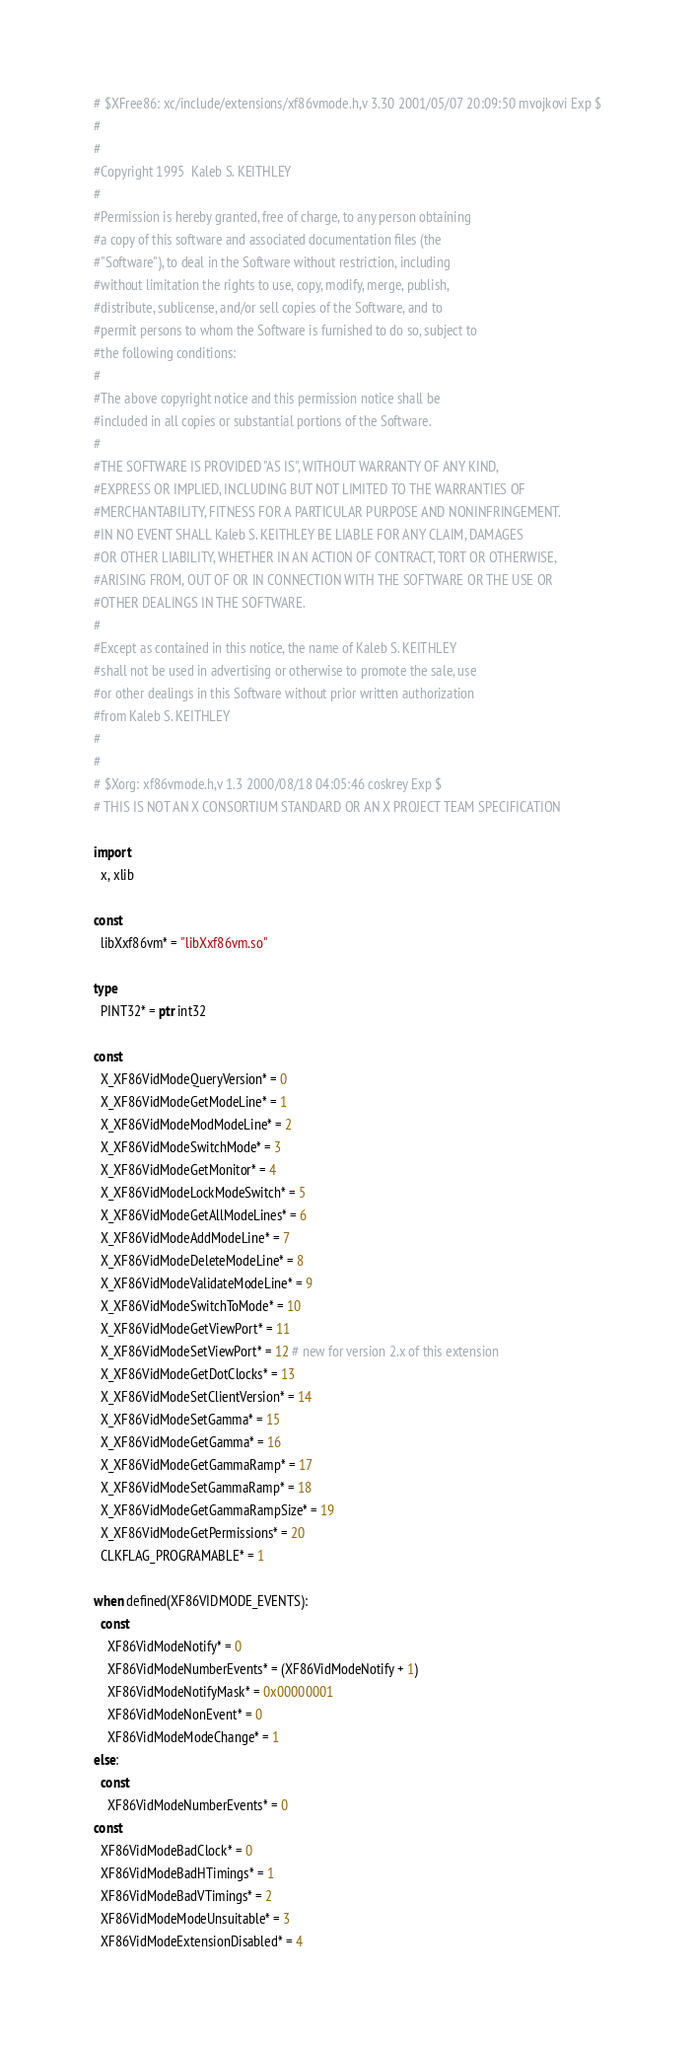Convert code to text. <code><loc_0><loc_0><loc_500><loc_500><_Nim_># $XFree86: xc/include/extensions/xf86vmode.h,v 3.30 2001/05/07 20:09:50 mvojkovi Exp $
#
#
#Copyright 1995  Kaleb S. KEITHLEY
#
#Permission is hereby granted, free of charge, to any person obtaining
#a copy of this software and associated documentation files (the
#"Software"), to deal in the Software without restriction, including
#without limitation the rights to use, copy, modify, merge, publish,
#distribute, sublicense, and/or sell copies of the Software, and to
#permit persons to whom the Software is furnished to do so, subject to
#the following conditions:
#
#The above copyright notice and this permission notice shall be
#included in all copies or substantial portions of the Software.
#
#THE SOFTWARE IS PROVIDED "AS IS", WITHOUT WARRANTY OF ANY KIND,
#EXPRESS OR IMPLIED, INCLUDING BUT NOT LIMITED TO THE WARRANTIES OF
#MERCHANTABILITY, FITNESS FOR A PARTICULAR PURPOSE AND NONINFRINGEMENT.
#IN NO EVENT SHALL Kaleb S. KEITHLEY BE LIABLE FOR ANY CLAIM, DAMAGES
#OR OTHER LIABILITY, WHETHER IN AN ACTION OF CONTRACT, TORT OR OTHERWISE,
#ARISING FROM, OUT OF OR IN CONNECTION WITH THE SOFTWARE OR THE USE OR
#OTHER DEALINGS IN THE SOFTWARE.
#
#Except as contained in this notice, the name of Kaleb S. KEITHLEY
#shall not be used in advertising or otherwise to promote the sale, use
#or other dealings in this Software without prior written authorization
#from Kaleb S. KEITHLEY
#
#
# $Xorg: xf86vmode.h,v 1.3 2000/08/18 04:05:46 coskrey Exp $
# THIS IS NOT AN X CONSORTIUM STANDARD OR AN X PROJECT TEAM SPECIFICATION

import
  x, xlib

const
  libXxf86vm* = "libXxf86vm.so"

type
  PINT32* = ptr int32

const
  X_XF86VidModeQueryVersion* = 0
  X_XF86VidModeGetModeLine* = 1
  X_XF86VidModeModModeLine* = 2
  X_XF86VidModeSwitchMode* = 3
  X_XF86VidModeGetMonitor* = 4
  X_XF86VidModeLockModeSwitch* = 5
  X_XF86VidModeGetAllModeLines* = 6
  X_XF86VidModeAddModeLine* = 7
  X_XF86VidModeDeleteModeLine* = 8
  X_XF86VidModeValidateModeLine* = 9
  X_XF86VidModeSwitchToMode* = 10
  X_XF86VidModeGetViewPort* = 11
  X_XF86VidModeSetViewPort* = 12 # new for version 2.x of this extension
  X_XF86VidModeGetDotClocks* = 13
  X_XF86VidModeSetClientVersion* = 14
  X_XF86VidModeSetGamma* = 15
  X_XF86VidModeGetGamma* = 16
  X_XF86VidModeGetGammaRamp* = 17
  X_XF86VidModeSetGammaRamp* = 18
  X_XF86VidModeGetGammaRampSize* = 19
  X_XF86VidModeGetPermissions* = 20
  CLKFLAG_PROGRAMABLE* = 1

when defined(XF86VIDMODE_EVENTS):
  const
    XF86VidModeNotify* = 0
    XF86VidModeNumberEvents* = (XF86VidModeNotify + 1)
    XF86VidModeNotifyMask* = 0x00000001
    XF86VidModeNonEvent* = 0
    XF86VidModeModeChange* = 1
else:
  const
    XF86VidModeNumberEvents* = 0
const
  XF86VidModeBadClock* = 0
  XF86VidModeBadHTimings* = 1
  XF86VidModeBadVTimings* = 2
  XF86VidModeModeUnsuitable* = 3
  XF86VidModeExtensionDisabled* = 4</code> 